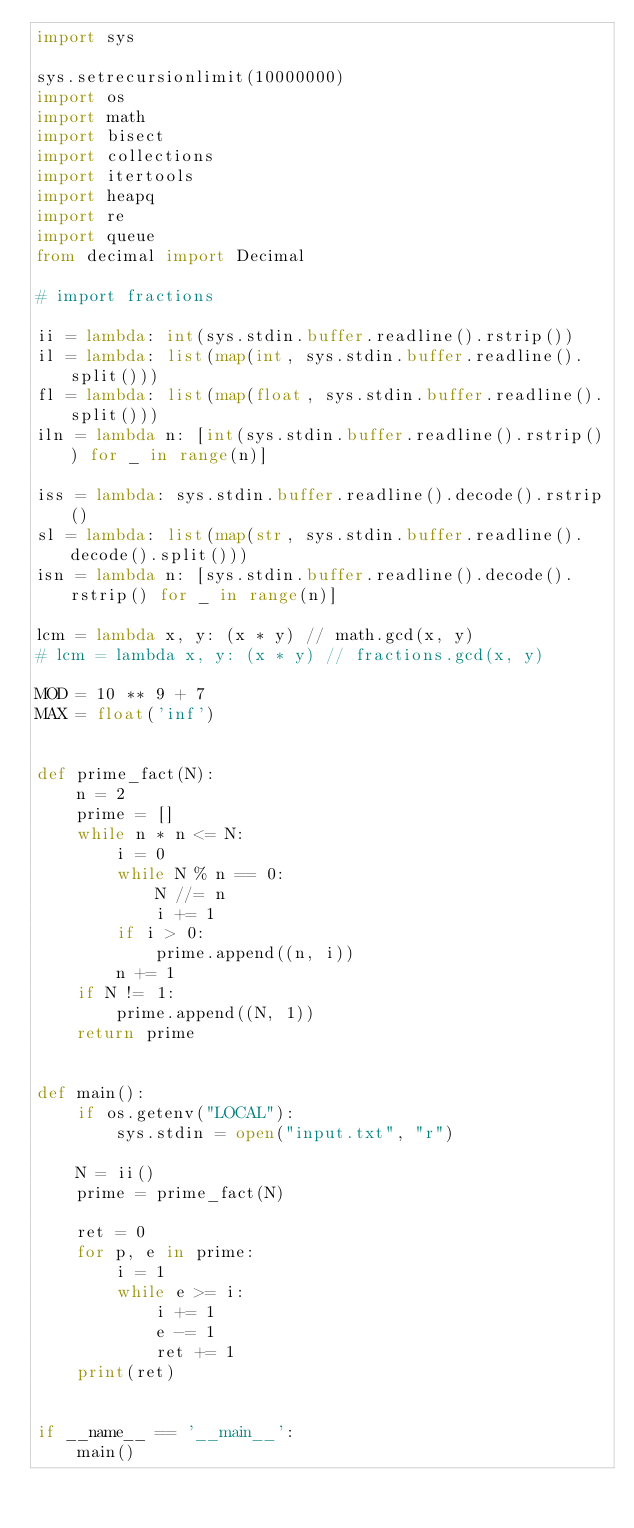<code> <loc_0><loc_0><loc_500><loc_500><_Python_>import sys

sys.setrecursionlimit(10000000)
import os
import math
import bisect
import collections
import itertools
import heapq
import re
import queue
from decimal import Decimal

# import fractions

ii = lambda: int(sys.stdin.buffer.readline().rstrip())
il = lambda: list(map(int, sys.stdin.buffer.readline().split()))
fl = lambda: list(map(float, sys.stdin.buffer.readline().split()))
iln = lambda n: [int(sys.stdin.buffer.readline().rstrip()) for _ in range(n)]

iss = lambda: sys.stdin.buffer.readline().decode().rstrip()
sl = lambda: list(map(str, sys.stdin.buffer.readline().decode().split()))
isn = lambda n: [sys.stdin.buffer.readline().decode().rstrip() for _ in range(n)]

lcm = lambda x, y: (x * y) // math.gcd(x, y)
# lcm = lambda x, y: (x * y) // fractions.gcd(x, y)

MOD = 10 ** 9 + 7
MAX = float('inf')


def prime_fact(N):
    n = 2
    prime = []
    while n * n <= N:
        i = 0
        while N % n == 0:
            N //= n
            i += 1
        if i > 0:
            prime.append((n, i))
        n += 1
    if N != 1:
        prime.append((N, 1))
    return prime


def main():
    if os.getenv("LOCAL"):
        sys.stdin = open("input.txt", "r")

    N = ii()
    prime = prime_fact(N)

    ret = 0
    for p, e in prime:
        i = 1
        while e >= i:
            i += 1
            e -= 1
            ret += 1
    print(ret)


if __name__ == '__main__':
    main()
</code> 